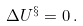<formula> <loc_0><loc_0><loc_500><loc_500>\Delta U ^ { \S } = 0 \, .</formula> 